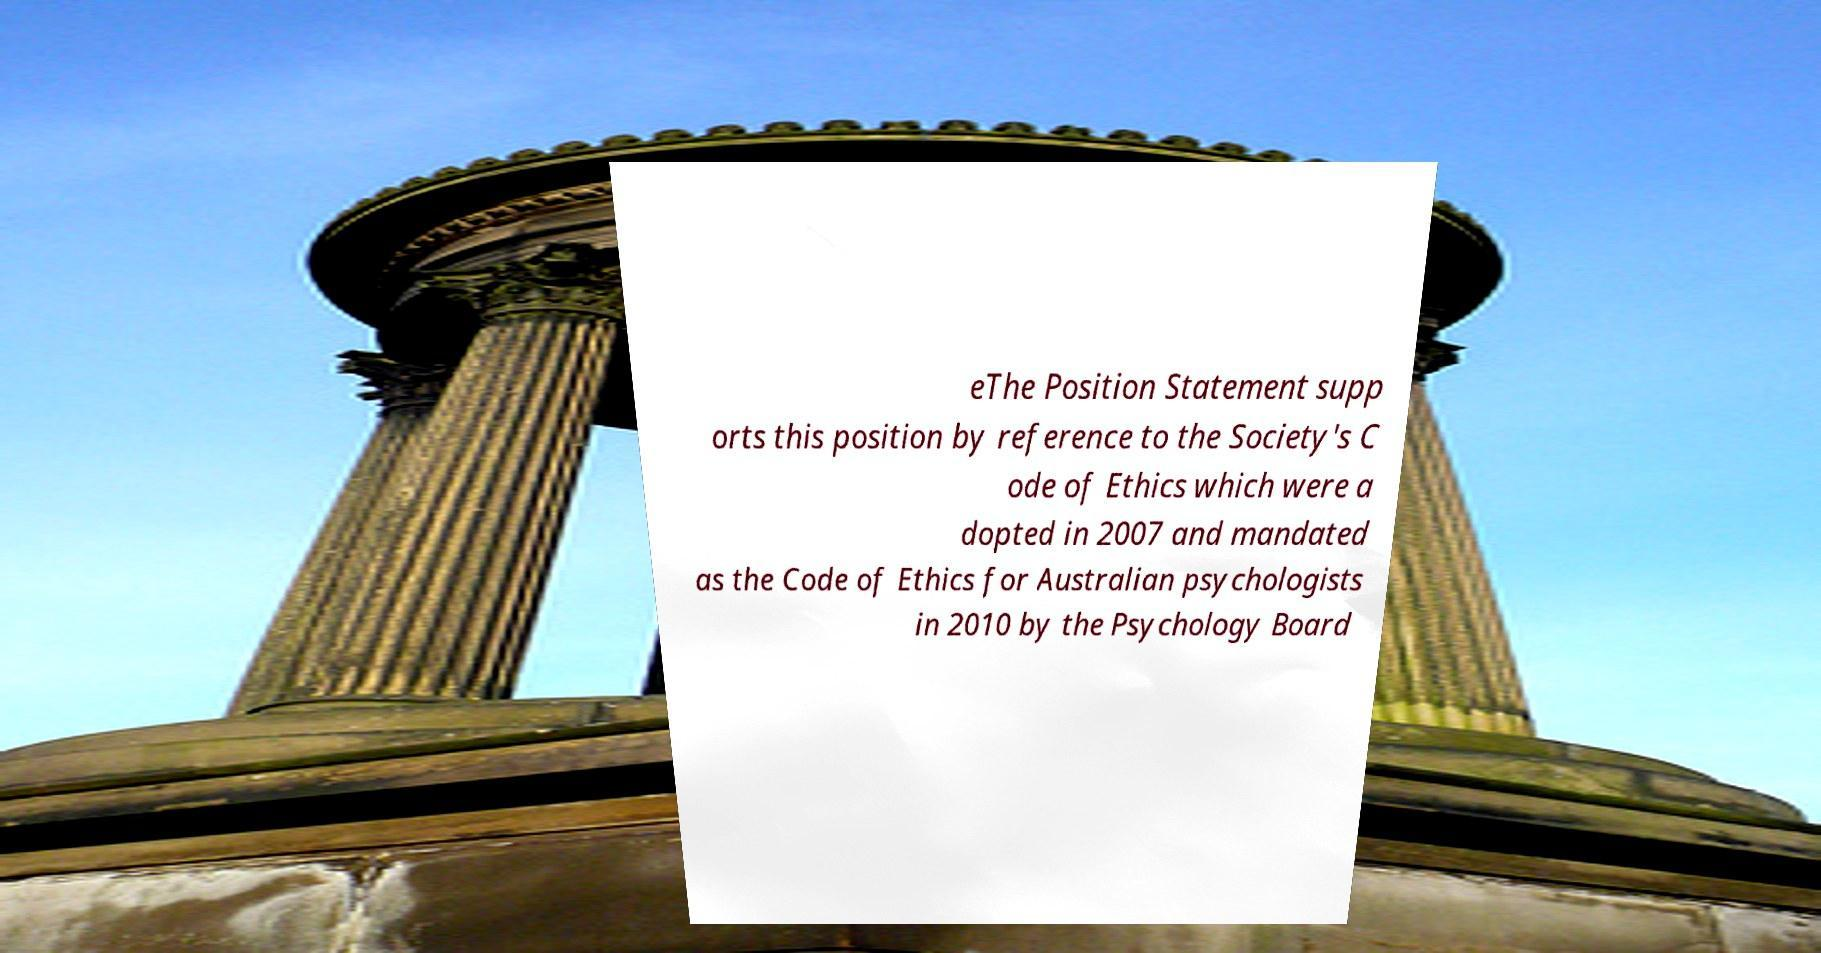Can you accurately transcribe the text from the provided image for me? eThe Position Statement supp orts this position by reference to the Society's C ode of Ethics which were a dopted in 2007 and mandated as the Code of Ethics for Australian psychologists in 2010 by the Psychology Board 